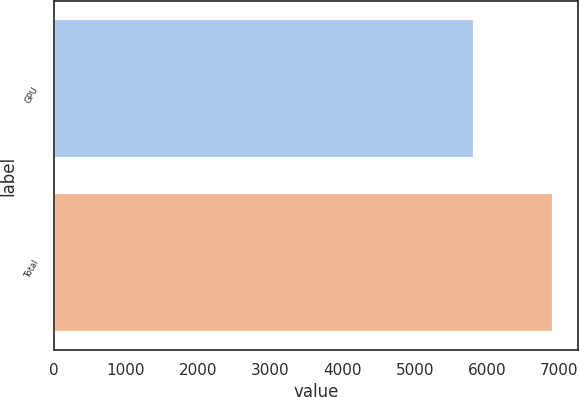Convert chart to OTSL. <chart><loc_0><loc_0><loc_500><loc_500><bar_chart><fcel>GPU<fcel>Total<nl><fcel>5822<fcel>6910<nl></chart> 